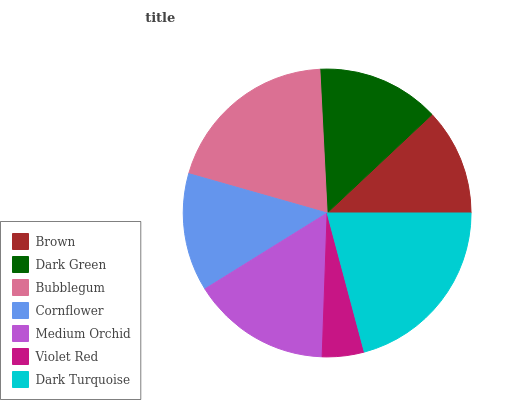Is Violet Red the minimum?
Answer yes or no. Yes. Is Dark Turquoise the maximum?
Answer yes or no. Yes. Is Dark Green the minimum?
Answer yes or no. No. Is Dark Green the maximum?
Answer yes or no. No. Is Dark Green greater than Brown?
Answer yes or no. Yes. Is Brown less than Dark Green?
Answer yes or no. Yes. Is Brown greater than Dark Green?
Answer yes or no. No. Is Dark Green less than Brown?
Answer yes or no. No. Is Dark Green the high median?
Answer yes or no. Yes. Is Dark Green the low median?
Answer yes or no. Yes. Is Medium Orchid the high median?
Answer yes or no. No. Is Brown the low median?
Answer yes or no. No. 